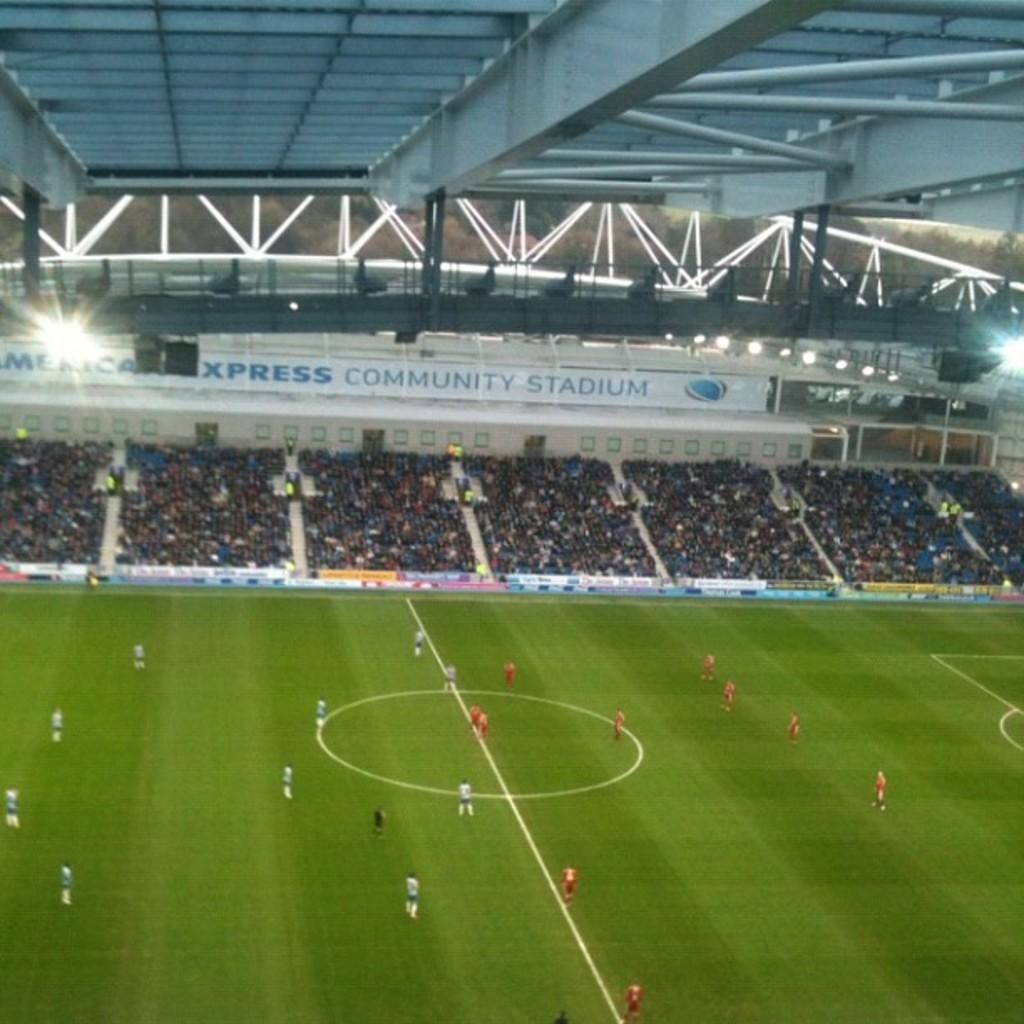What word is before stadium on the large banner?
Ensure brevity in your answer.  Community. 